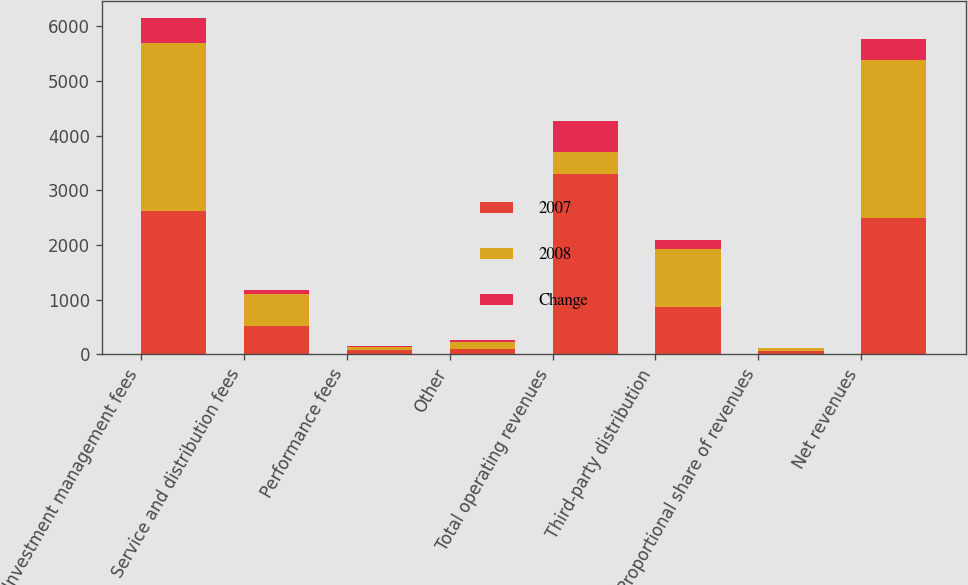Convert chart. <chart><loc_0><loc_0><loc_500><loc_500><stacked_bar_chart><ecel><fcel>Investment management fees<fcel>Service and distribution fees<fcel>Performance fees<fcel>Other<fcel>Total operating revenues<fcel>Third-party distribution<fcel>Proportional share of revenues<fcel>Net revenues<nl><fcel>2007<fcel>2617.8<fcel>512.5<fcel>75.1<fcel>102.2<fcel>3307.6<fcel>875.5<fcel>57.3<fcel>2489.4<nl><fcel>2008<fcel>3080.1<fcel>593.1<fcel>70.3<fcel>135.4<fcel>399<fcel>1051.1<fcel>60.6<fcel>2888.4<nl><fcel>Change<fcel>462.3<fcel>80.6<fcel>4.8<fcel>33.2<fcel>571.3<fcel>175.6<fcel>3.3<fcel>399<nl></chart> 